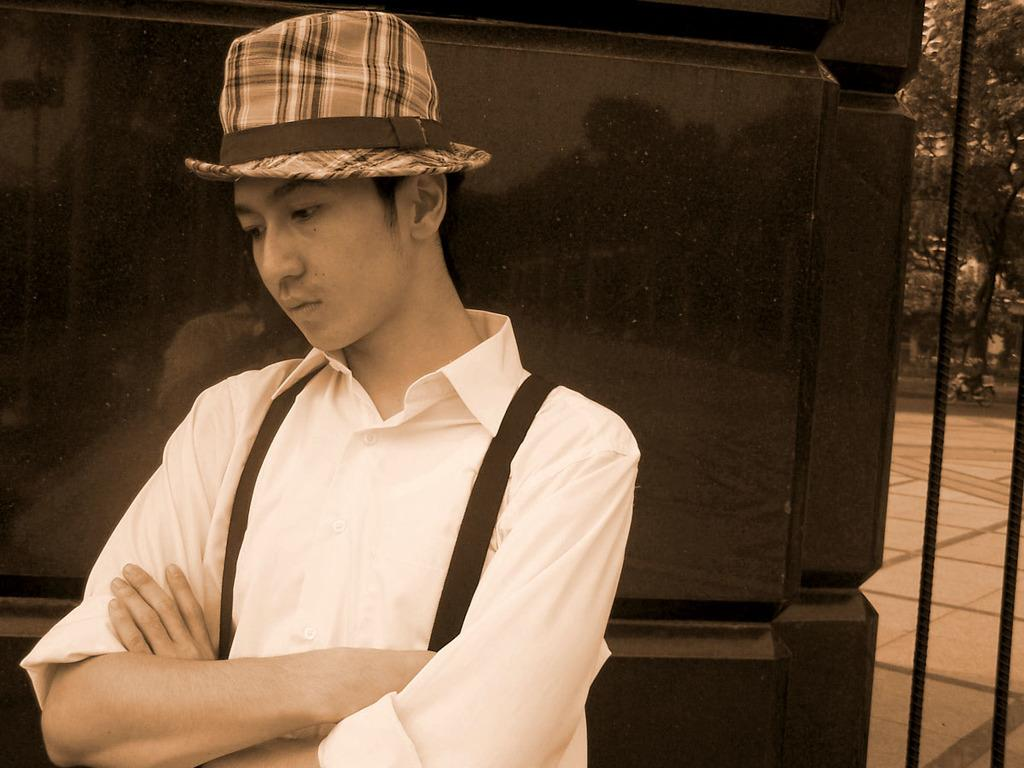Who is present in the image? There is a man in the image. What is the man wearing on his upper body? The man is wearing a shirt. What type of headwear is the man wearing? The man is wearing a hat on his head. What can be seen behind the man in the image? There is a wall behind the man. What type of vegetation is on the right side of the image? There are trees on the right side of the image. What is the color scheme of the image? The image is black and white. What type of train can be seen in the image? There is no train present in the image; it features a man wearing a shirt and a hat. How many quarters are visible in the image? There are no quarters present in the image. 